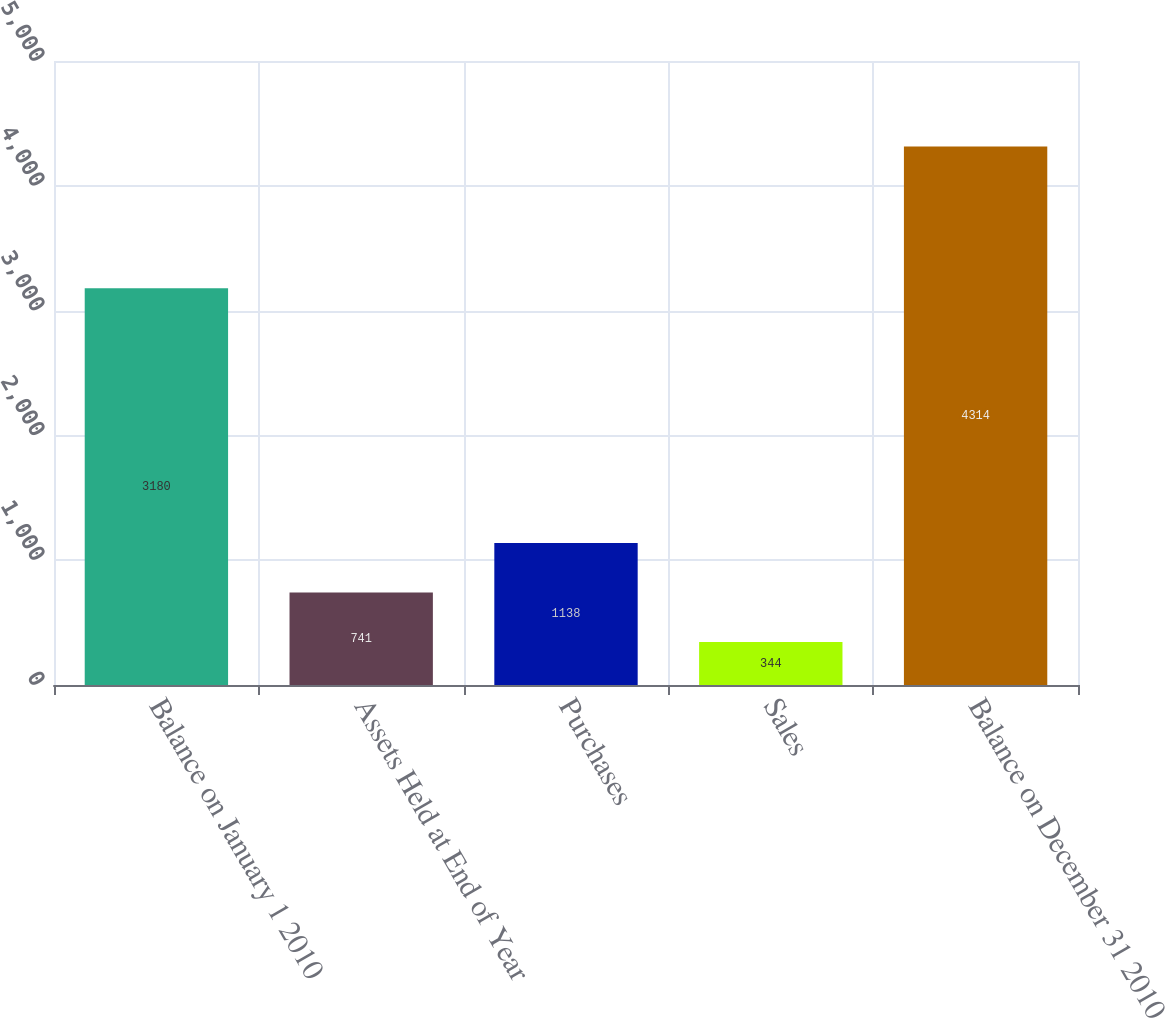<chart> <loc_0><loc_0><loc_500><loc_500><bar_chart><fcel>Balance on January 1 2010<fcel>Assets Held at End of Year<fcel>Purchases<fcel>Sales<fcel>Balance on December 31 2010<nl><fcel>3180<fcel>741<fcel>1138<fcel>344<fcel>4314<nl></chart> 